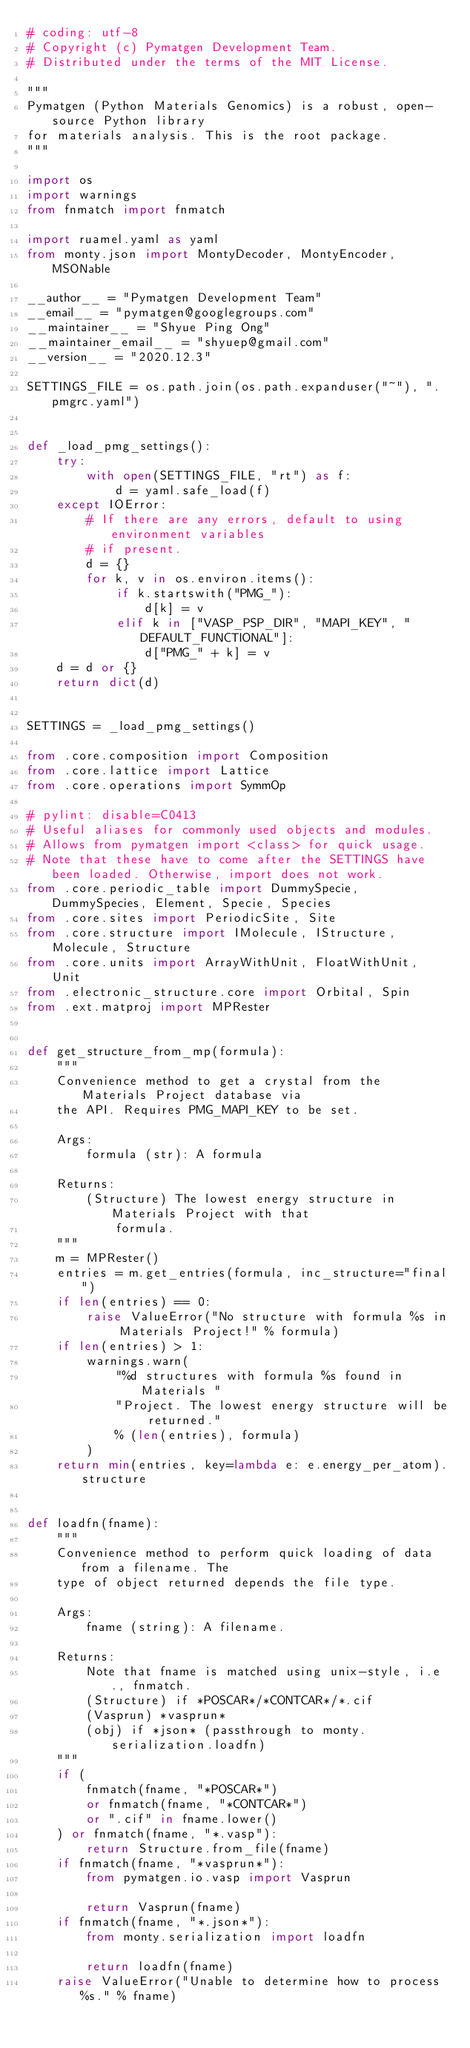Convert code to text. <code><loc_0><loc_0><loc_500><loc_500><_Python_># coding: utf-8
# Copyright (c) Pymatgen Development Team.
# Distributed under the terms of the MIT License.

"""
Pymatgen (Python Materials Genomics) is a robust, open-source Python library
for materials analysis. This is the root package.
"""

import os
import warnings
from fnmatch import fnmatch

import ruamel.yaml as yaml
from monty.json import MontyDecoder, MontyEncoder, MSONable

__author__ = "Pymatgen Development Team"
__email__ = "pymatgen@googlegroups.com"
__maintainer__ = "Shyue Ping Ong"
__maintainer_email__ = "shyuep@gmail.com"
__version__ = "2020.12.3"

SETTINGS_FILE = os.path.join(os.path.expanduser("~"), ".pmgrc.yaml")


def _load_pmg_settings():
    try:
        with open(SETTINGS_FILE, "rt") as f:
            d = yaml.safe_load(f)
    except IOError:
        # If there are any errors, default to using environment variables
        # if present.
        d = {}
        for k, v in os.environ.items():
            if k.startswith("PMG_"):
                d[k] = v
            elif k in ["VASP_PSP_DIR", "MAPI_KEY", "DEFAULT_FUNCTIONAL"]:
                d["PMG_" + k] = v
    d = d or {}
    return dict(d)


SETTINGS = _load_pmg_settings()

from .core.composition import Composition
from .core.lattice import Lattice
from .core.operations import SymmOp

# pylint: disable=C0413
# Useful aliases for commonly used objects and modules.
# Allows from pymatgen import <class> for quick usage.
# Note that these have to come after the SETTINGS have been loaded. Otherwise, import does not work.
from .core.periodic_table import DummySpecie, DummySpecies, Element, Specie, Species
from .core.sites import PeriodicSite, Site
from .core.structure import IMolecule, IStructure, Molecule, Structure
from .core.units import ArrayWithUnit, FloatWithUnit, Unit
from .electronic_structure.core import Orbital, Spin
from .ext.matproj import MPRester


def get_structure_from_mp(formula):
    """
    Convenience method to get a crystal from the Materials Project database via
    the API. Requires PMG_MAPI_KEY to be set.

    Args:
        formula (str): A formula

    Returns:
        (Structure) The lowest energy structure in Materials Project with that
            formula.
    """
    m = MPRester()
    entries = m.get_entries(formula, inc_structure="final")
    if len(entries) == 0:
        raise ValueError("No structure with formula %s in Materials Project!" % formula)
    if len(entries) > 1:
        warnings.warn(
            "%d structures with formula %s found in Materials "
            "Project. The lowest energy structure will be returned."
            % (len(entries), formula)
        )
    return min(entries, key=lambda e: e.energy_per_atom).structure


def loadfn(fname):
    """
    Convenience method to perform quick loading of data from a filename. The
    type of object returned depends the file type.

    Args:
        fname (string): A filename.

    Returns:
        Note that fname is matched using unix-style, i.e., fnmatch.
        (Structure) if *POSCAR*/*CONTCAR*/*.cif
        (Vasprun) *vasprun*
        (obj) if *json* (passthrough to monty.serialization.loadfn)
    """
    if (
        fnmatch(fname, "*POSCAR*")
        or fnmatch(fname, "*CONTCAR*")
        or ".cif" in fname.lower()
    ) or fnmatch(fname, "*.vasp"):
        return Structure.from_file(fname)
    if fnmatch(fname, "*vasprun*"):
        from pymatgen.io.vasp import Vasprun

        return Vasprun(fname)
    if fnmatch(fname, "*.json*"):
        from monty.serialization import loadfn

        return loadfn(fname)
    raise ValueError("Unable to determine how to process %s." % fname)
</code> 